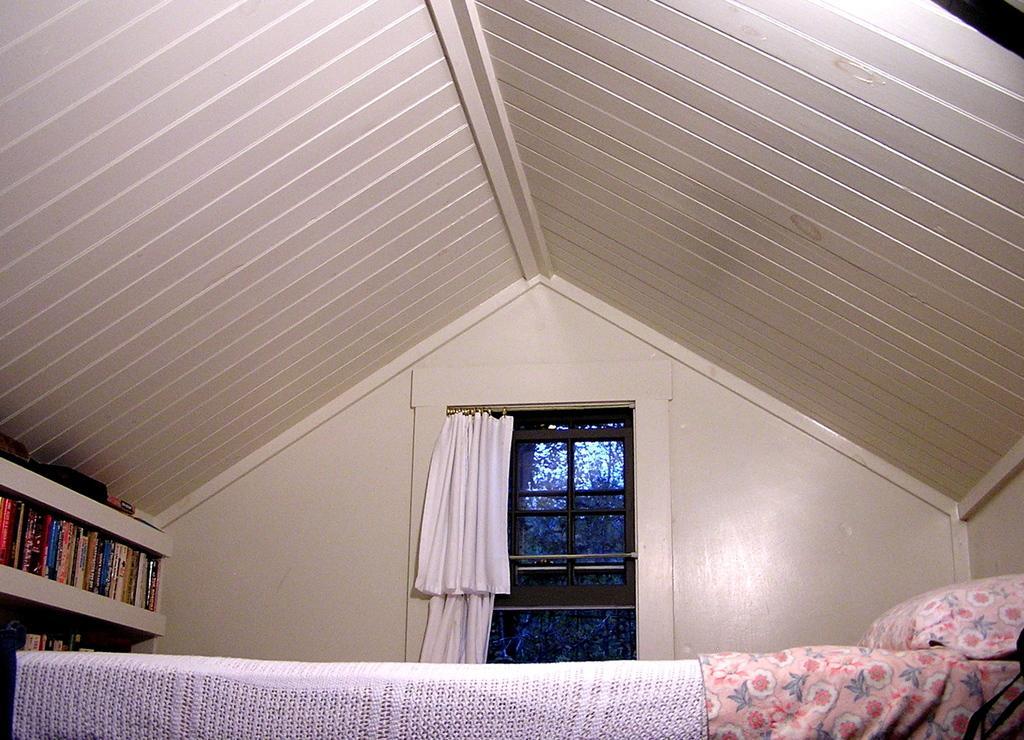How would you summarize this image in a sentence or two? In this picture I can see a bed and pillow. I can see a glass window with the curtain. I can see a number of books on the rack on the left side. I can see wooden roof. 